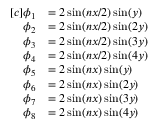<formula> <loc_0><loc_0><loc_500><loc_500>\begin{array} { r l } { [ c ] \phi _ { 1 } } & { = 2 \sin ( n x / 2 ) \sin ( y ) } \\ { \phi _ { 2 } } & { = 2 \sin ( n x / 2 ) \sin ( 2 y ) } \\ { \phi _ { 3 } } & { = 2 \sin ( n x / 2 ) \sin ( 3 y ) } \\ { \phi _ { 4 } } & { = 2 \sin ( n x / 2 ) \sin ( 4 y ) } \\ { \phi _ { 5 } } & { = 2 \sin ( n x ) \sin ( y ) } \\ { \phi _ { 6 } } & { = 2 \sin ( n x ) \sin ( 2 y ) } \\ { \phi _ { 7 } } & { = 2 \sin ( n x ) \sin ( 3 y ) } \\ { \phi _ { 8 } } & { = 2 \sin ( n x ) \sin ( 4 y ) } \end{array}</formula> 